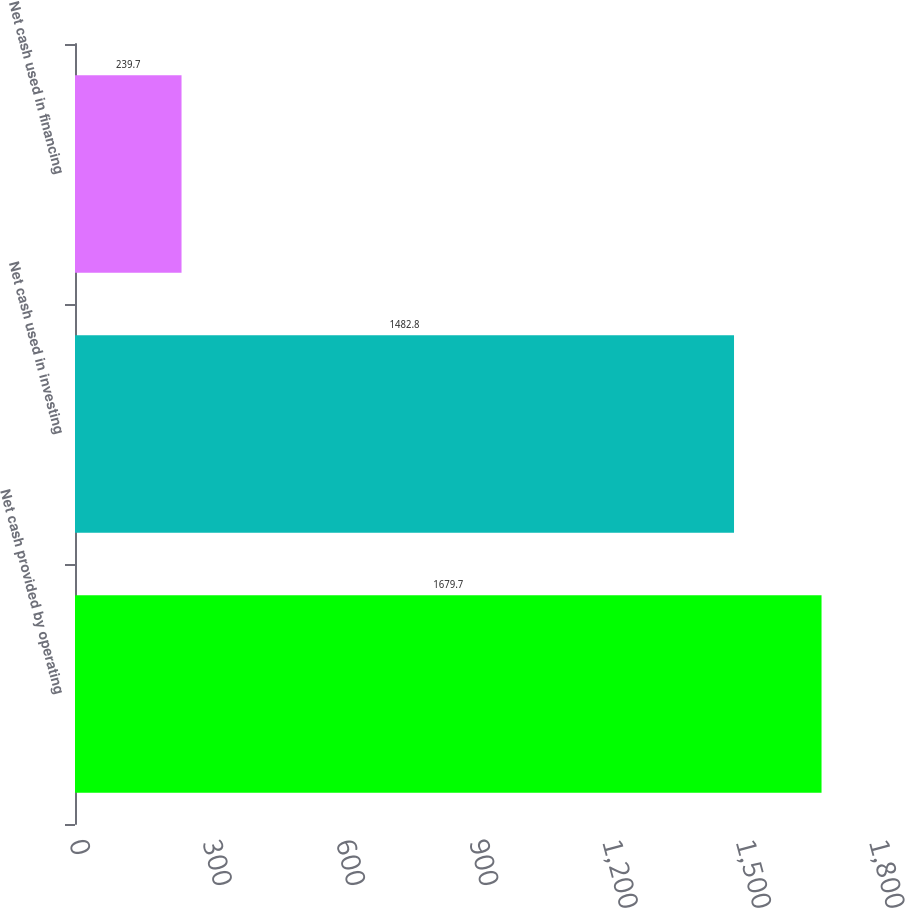Convert chart. <chart><loc_0><loc_0><loc_500><loc_500><bar_chart><fcel>Net cash provided by operating<fcel>Net cash used in investing<fcel>Net cash used in financing<nl><fcel>1679.7<fcel>1482.8<fcel>239.7<nl></chart> 